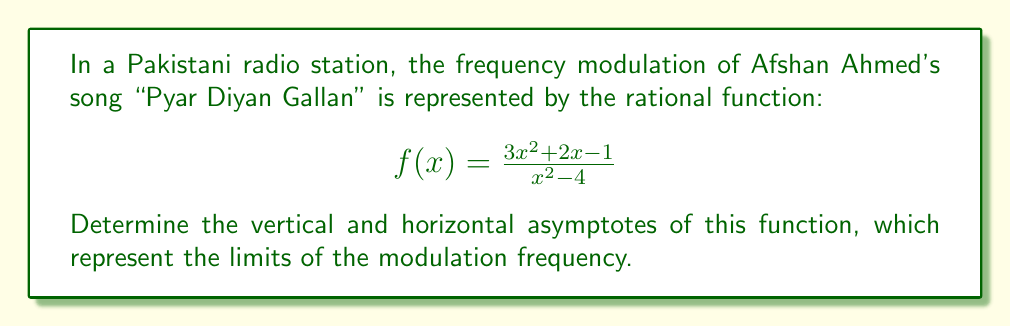Solve this math problem. To find the asymptotes of the rational function, we need to follow these steps:

1. Vertical asymptotes:
   Find the values of x that make the denominator zero.
   $$x^2 - 4 = 0$$
   $$(x+2)(x-2) = 0$$
   $$x = -2 \text{ or } x = 2$$
   Therefore, the vertical asymptotes are at x = -2 and x = 2.

2. Horizontal asymptote:
   Compare the degrees of the numerator and denominator.
   - Numerator degree: 2
   - Denominator degree: 2
   
   Since the degrees are equal, the horizontal asymptote is the ratio of the leading coefficients:
   $$\lim_{x \to \infty} \frac{3x^2 + 2x - 1}{x^2 - 4} = \frac{3}{1} = 3$$

   Therefore, the horizontal asymptote is y = 3.

3. Slant asymptotes:
   Since the degree of the numerator is not greater than the degree of the denominator, there are no slant asymptotes.
Answer: Vertical asymptotes: x = -2, x = 2; Horizontal asymptote: y = 3 